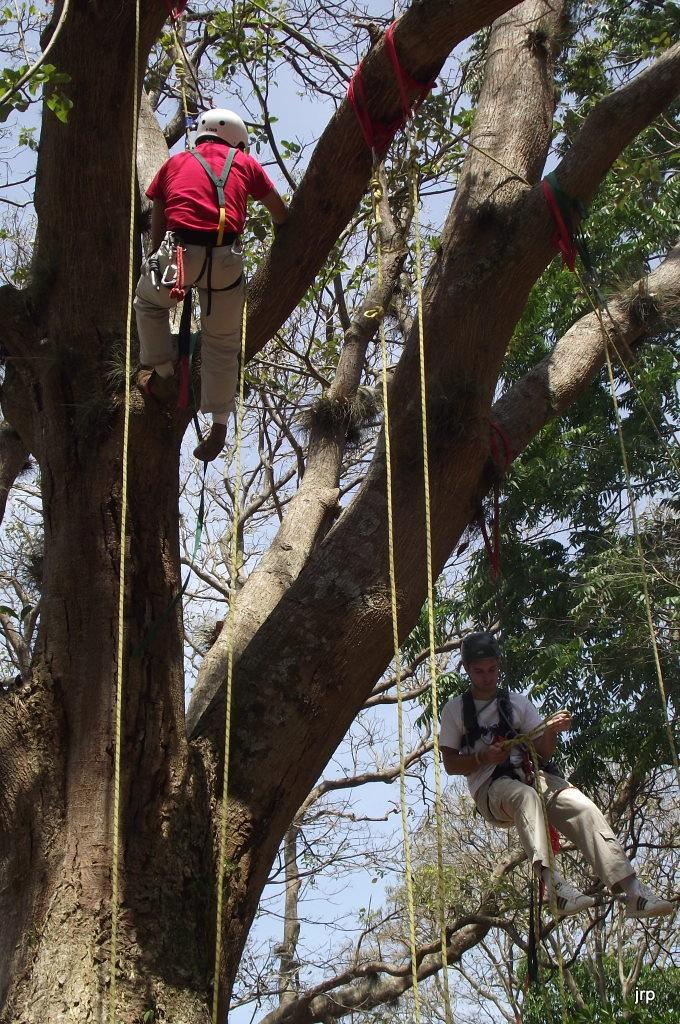How many people are in the image? There are two people in the image. What are the people doing in the image? The two people are climbing a tree. How are the people climbing the tree? The people are using a rope to climb the tree. What can be seen behind the tree in the image? The sky is partially visible behind the tree. What type of apple is the mom holding for the boy in the image? There is no mom or boy present in the image, nor is there an apple. 